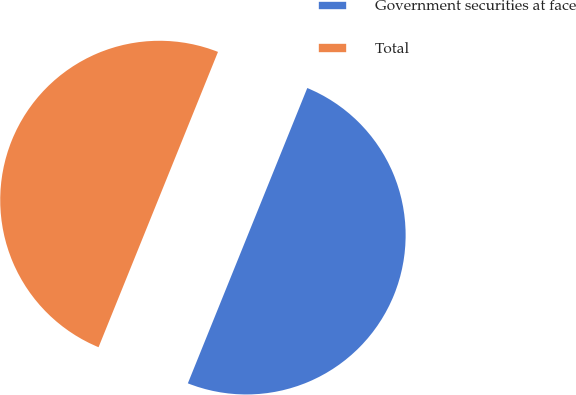Convert chart to OTSL. <chart><loc_0><loc_0><loc_500><loc_500><pie_chart><fcel>Government securities at face<fcel>Total<nl><fcel>50.0%<fcel>50.0%<nl></chart> 